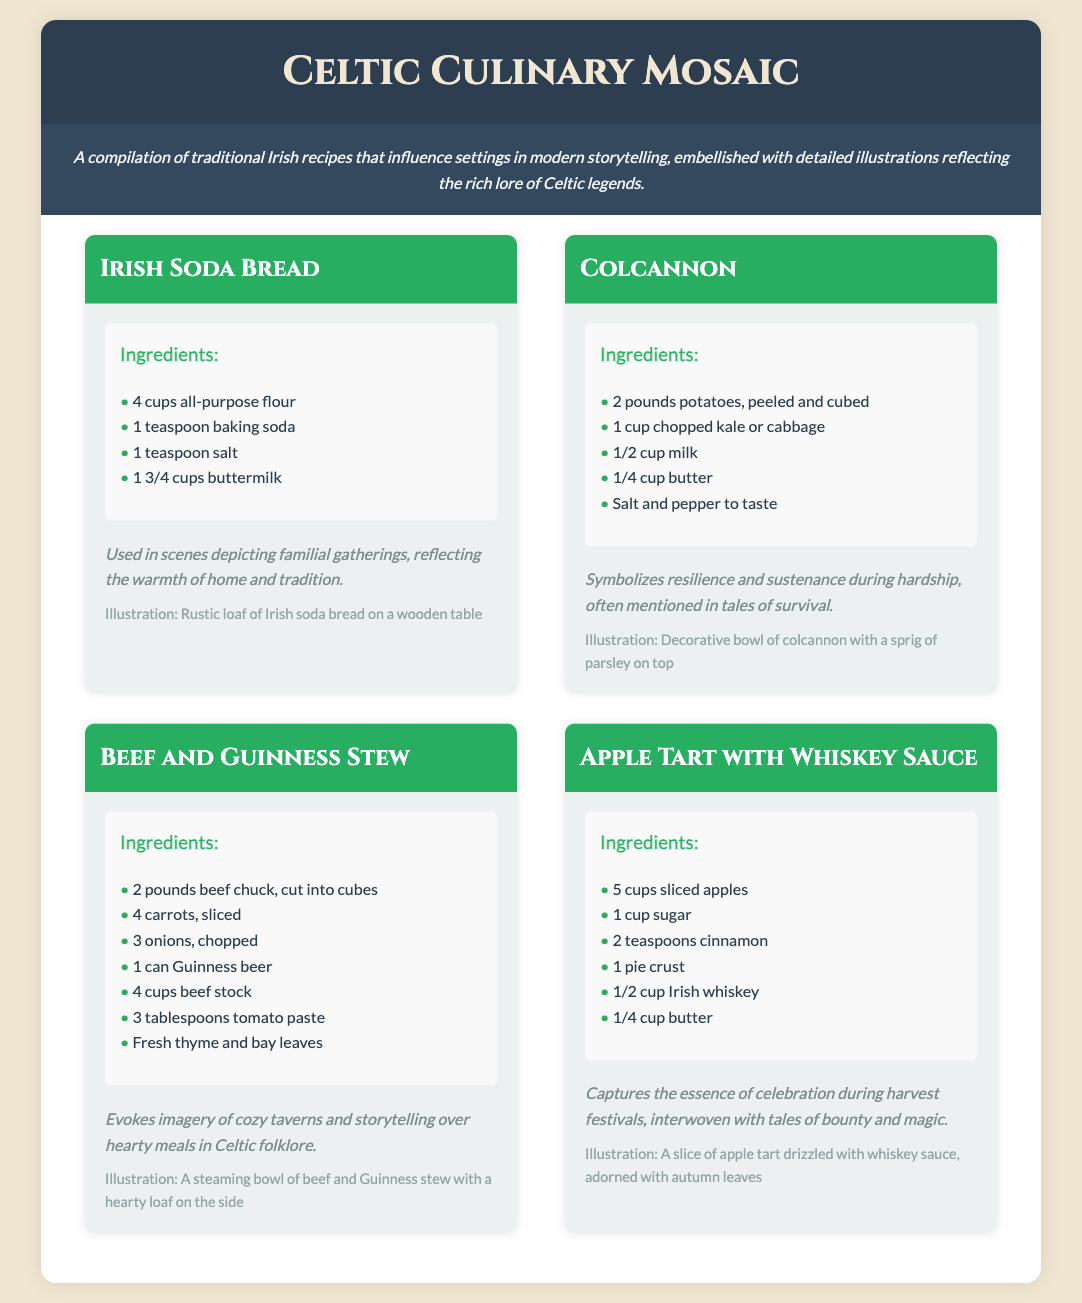What is the title of the document? The title is highlighted prominently at the top of the document, which is "Celtic Culinary Mosaic."
Answer: Celtic Culinary Mosaic How many recipes are included in the document? The document lists a total of four recipes presented in separate sections.
Answer: 4 What is one ingredient in Irish Soda Bread? The ingredients section lists the key components of the recipe, including all-purpose flour, baking soda, salt, and buttermilk, among others.
Answer: all-purpose flour What is the primary vegetable in Colcannon? The ingredients for Colcannon include potatoes and either kale or cabbage, with potatoes being the base vegetable.
Answer: potatoes Which recipe evokes imagery of cozy taverns? The narrative section describes the Beef and Guinness Stew as evoking imagery of cozy taverns and storytelling over hearty meals.
Answer: Beef and Guinness Stew What capitalizes on themes of celebration and bounty? The Apple Tart with Whiskey Sauce captures the essence of celebration during harvest festivals and is associated with tales of bounty.
Answer: Apple Tart with Whiskey Sauce How is Irish Soda Bread described in the narrative? The narrative section reflects on its use during familial gatherings, emphasizing warmth and tradition.
Answer: warmth of home and tradition What is the illustration associated with Apple Tart? The document includes a specific description of the visual imagery accompanying the Apple Tart recipe, which features autumn leaves.
Answer: autumn leaves 